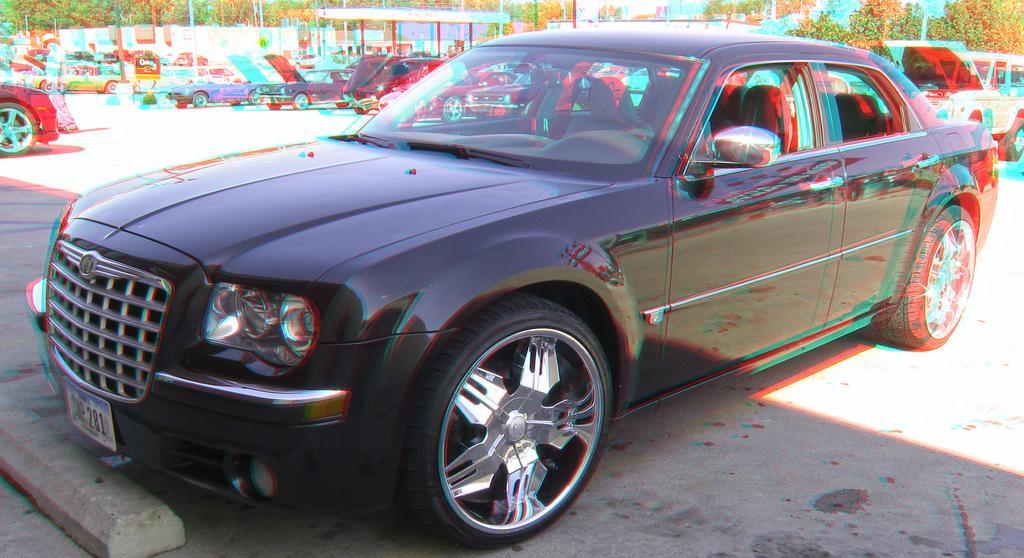Could you give a brief overview of what you see in this image? In the center of the image there is a black color car parked on the road. Image also consists of many trees and poles and also wall. 